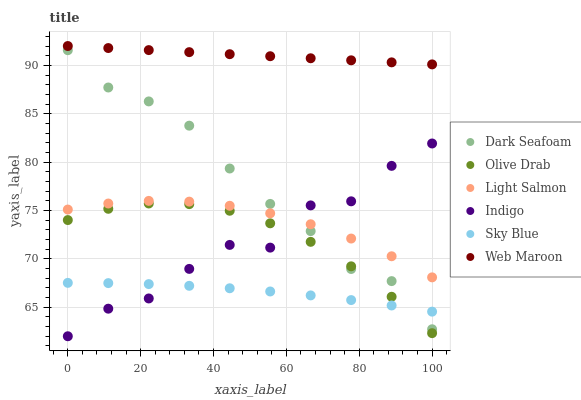Does Sky Blue have the minimum area under the curve?
Answer yes or no. Yes. Does Web Maroon have the maximum area under the curve?
Answer yes or no. Yes. Does Indigo have the minimum area under the curve?
Answer yes or no. No. Does Indigo have the maximum area under the curve?
Answer yes or no. No. Is Web Maroon the smoothest?
Answer yes or no. Yes. Is Indigo the roughest?
Answer yes or no. Yes. Is Indigo the smoothest?
Answer yes or no. No. Is Web Maroon the roughest?
Answer yes or no. No. Does Indigo have the lowest value?
Answer yes or no. Yes. Does Web Maroon have the lowest value?
Answer yes or no. No. Does Web Maroon have the highest value?
Answer yes or no. Yes. Does Indigo have the highest value?
Answer yes or no. No. Is Olive Drab less than Light Salmon?
Answer yes or no. Yes. Is Web Maroon greater than Light Salmon?
Answer yes or no. Yes. Does Indigo intersect Sky Blue?
Answer yes or no. Yes. Is Indigo less than Sky Blue?
Answer yes or no. No. Is Indigo greater than Sky Blue?
Answer yes or no. No. Does Olive Drab intersect Light Salmon?
Answer yes or no. No. 